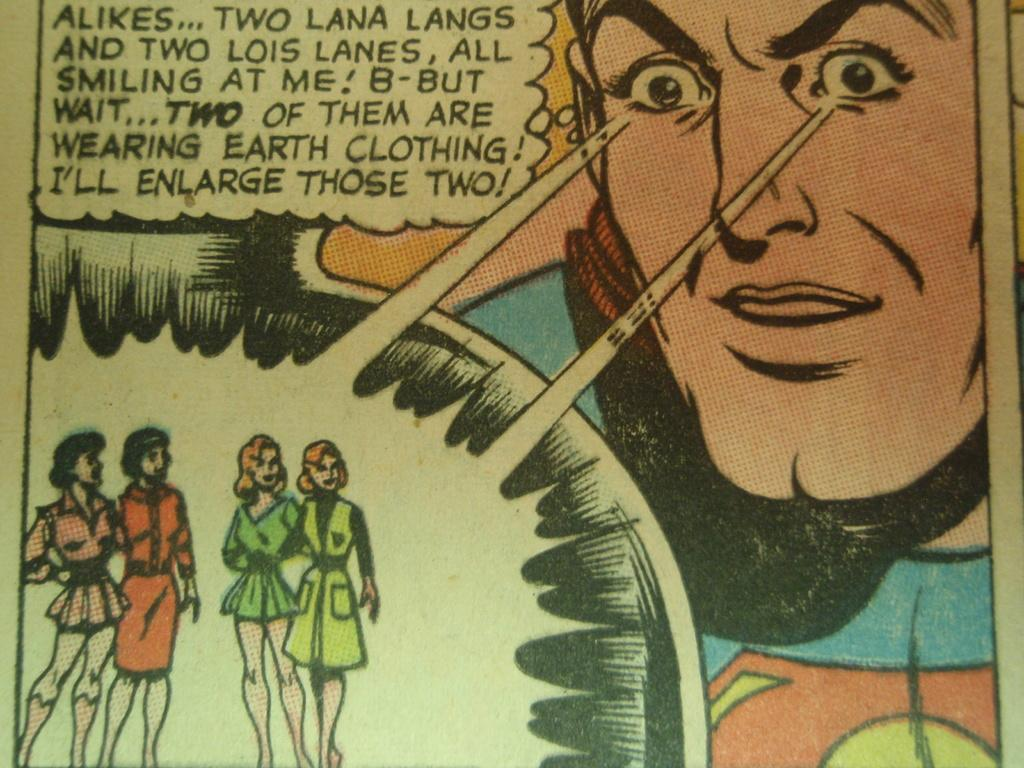What is the main subject of the picture? The main subject of the picture is images of different persons. Can you describe the text in the image? There is text written in the left top corner of the image. How many birds are flying in the image? There are no birds present in the image. What is the name of the nation depicted in the image? The image does not depict any nation; it features images of different persons and text. 